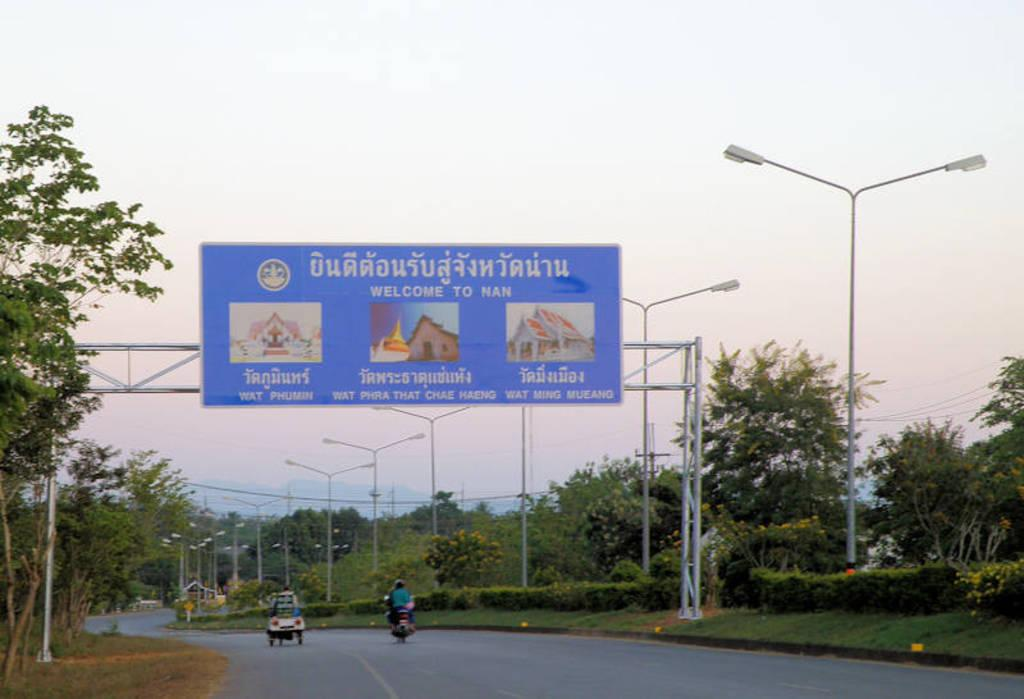<image>
Present a compact description of the photo's key features. a road sign is hung welcoming you to Nan 